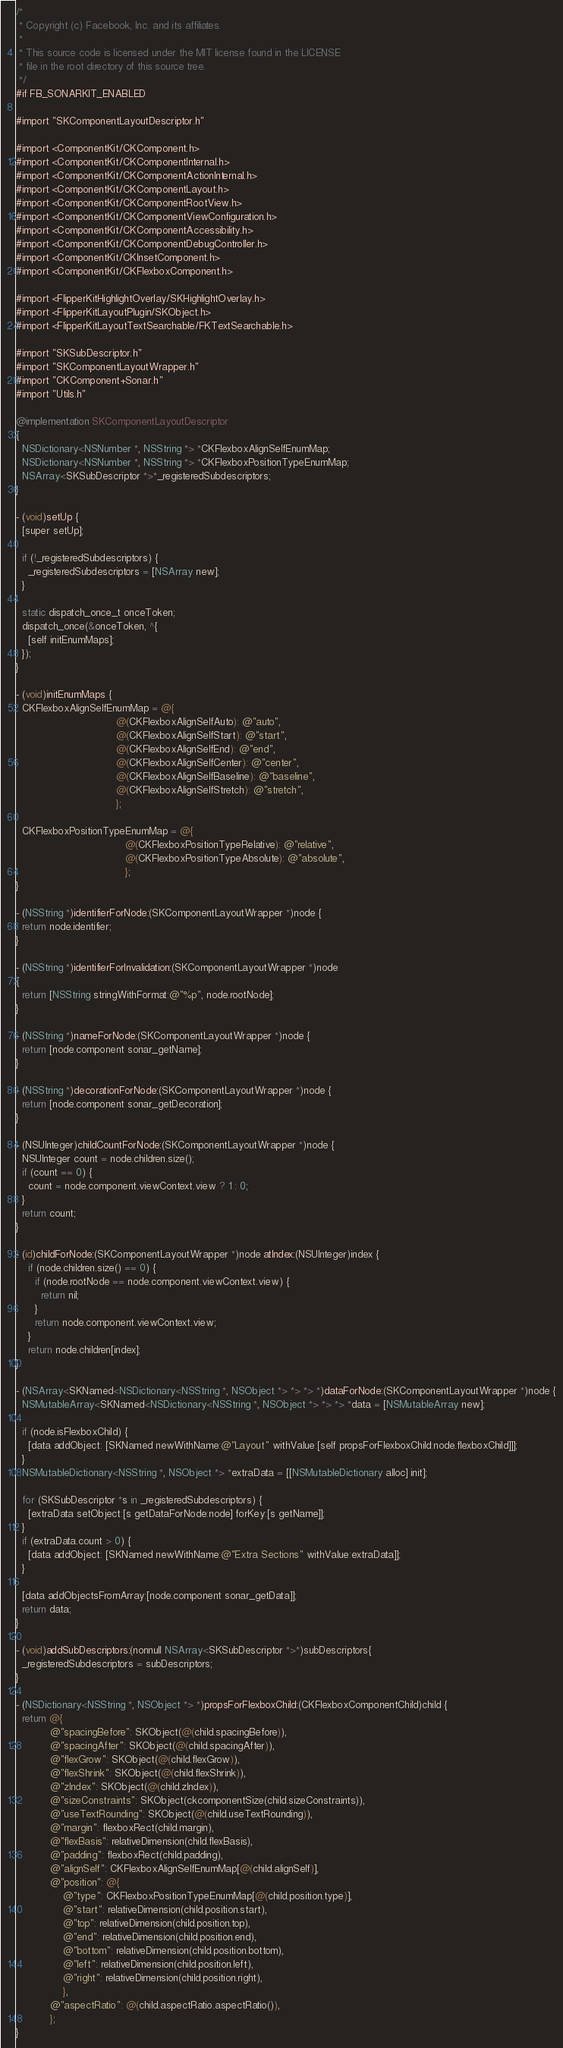<code> <loc_0><loc_0><loc_500><loc_500><_ObjectiveC_>/*
 * Copyright (c) Facebook, Inc. and its affiliates.
 *
 * This source code is licensed under the MIT license found in the LICENSE
 * file in the root directory of this source tree.
 */
#if FB_SONARKIT_ENABLED

#import "SKComponentLayoutDescriptor.h"

#import <ComponentKit/CKComponent.h>
#import <ComponentKit/CKComponentInternal.h>
#import <ComponentKit/CKComponentActionInternal.h>
#import <ComponentKit/CKComponentLayout.h>
#import <ComponentKit/CKComponentRootView.h>
#import <ComponentKit/CKComponentViewConfiguration.h>
#import <ComponentKit/CKComponentAccessibility.h>
#import <ComponentKit/CKComponentDebugController.h>
#import <ComponentKit/CKInsetComponent.h>
#import <ComponentKit/CKFlexboxComponent.h>

#import <FlipperKitHighlightOverlay/SKHighlightOverlay.h>
#import <FlipperKitLayoutPlugin/SKObject.h>
#import <FlipperKitLayoutTextSearchable/FKTextSearchable.h>

#import "SKSubDescriptor.h"
#import "SKComponentLayoutWrapper.h"
#import "CKComponent+Sonar.h"
#import "Utils.h"

@implementation SKComponentLayoutDescriptor
{
  NSDictionary<NSNumber *, NSString *> *CKFlexboxAlignSelfEnumMap;
  NSDictionary<NSNumber *, NSString *> *CKFlexboxPositionTypeEnumMap;
  NSArray<SKSubDescriptor *>*_registeredSubdescriptors;
}

- (void)setUp {
  [super setUp];

  if (!_registeredSubdescriptors) {
    _registeredSubdescriptors = [NSArray new];
  }

  static dispatch_once_t onceToken;
  dispatch_once(&onceToken, ^{
    [self initEnumMaps];
  });
}

- (void)initEnumMaps {
  CKFlexboxAlignSelfEnumMap = @{
                                @(CKFlexboxAlignSelfAuto): @"auto",
                                @(CKFlexboxAlignSelfStart): @"start",
                                @(CKFlexboxAlignSelfEnd): @"end",
                                @(CKFlexboxAlignSelfCenter): @"center",
                                @(CKFlexboxAlignSelfBaseline): @"baseline",
                                @(CKFlexboxAlignSelfStretch): @"stretch",
                                };

  CKFlexboxPositionTypeEnumMap = @{
                                   @(CKFlexboxPositionTypeRelative): @"relative",
                                   @(CKFlexboxPositionTypeAbsolute): @"absolute",
                                   };
}

- (NSString *)identifierForNode:(SKComponentLayoutWrapper *)node {
  return node.identifier;
}

- (NSString *)identifierForInvalidation:(SKComponentLayoutWrapper *)node
{
  return [NSString stringWithFormat:@"%p", node.rootNode];
}

- (NSString *)nameForNode:(SKComponentLayoutWrapper *)node {
  return [node.component sonar_getName];
}

- (NSString *)decorationForNode:(SKComponentLayoutWrapper *)node {
  return [node.component sonar_getDecoration];
}

- (NSUInteger)childCountForNode:(SKComponentLayoutWrapper *)node {
  NSUInteger count = node.children.size();
  if (count == 0) {
    count = node.component.viewContext.view ? 1 : 0;
  }
  return count;
}

- (id)childForNode:(SKComponentLayoutWrapper *)node atIndex:(NSUInteger)index {
    if (node.children.size() == 0) {
      if (node.rootNode == node.component.viewContext.view) {
        return nil;
      }
      return node.component.viewContext.view;
    }
    return node.children[index];
}

- (NSArray<SKNamed<NSDictionary<NSString *, NSObject *> *> *> *)dataForNode:(SKComponentLayoutWrapper *)node {
  NSMutableArray<SKNamed<NSDictionary<NSString *, NSObject *> *> *> *data = [NSMutableArray new];

  if (node.isFlexboxChild) {
    [data addObject: [SKNamed newWithName:@"Layout" withValue:[self propsForFlexboxChild:node.flexboxChild]]];
  }
  NSMutableDictionary<NSString *, NSObject *> *extraData = [[NSMutableDictionary alloc] init];

  for (SKSubDescriptor *s in _registeredSubdescriptors) {
    [extraData setObject:[s getDataForNode:node] forKey:[s getName]];
  }
  if (extraData.count > 0) {
    [data addObject: [SKNamed newWithName:@"Extra Sections" withValue:extraData]];
  }

  [data addObjectsFromArray:[node.component sonar_getData]];
  return data;
}

- (void)addSubDescriptors:(nonnull NSArray<SKSubDescriptor *>*)subDescriptors{
  _registeredSubdescriptors = subDescriptors;
}

- (NSDictionary<NSString *, NSObject *> *)propsForFlexboxChild:(CKFlexboxComponentChild)child {
  return @{
           @"spacingBefore": SKObject(@(child.spacingBefore)),
           @"spacingAfter": SKObject(@(child.spacingAfter)),
           @"flexGrow": SKObject(@(child.flexGrow)),
           @"flexShrink": SKObject(@(child.flexShrink)),
           @"zIndex": SKObject(@(child.zIndex)),
           @"sizeConstraints": SKObject(ckcomponentSize(child.sizeConstraints)),
           @"useTextRounding": SKObject(@(child.useTextRounding)),
           @"margin": flexboxRect(child.margin),
           @"flexBasis": relativeDimension(child.flexBasis),
           @"padding": flexboxRect(child.padding),
           @"alignSelf": CKFlexboxAlignSelfEnumMap[@(child.alignSelf)],
           @"position": @{
               @"type": CKFlexboxPositionTypeEnumMap[@(child.position.type)],
               @"start": relativeDimension(child.position.start),
               @"top": relativeDimension(child.position.top),
               @"end": relativeDimension(child.position.end),
               @"bottom": relativeDimension(child.position.bottom),
               @"left": relativeDimension(child.position.left),
               @"right": relativeDimension(child.position.right),
               },
           @"aspectRatio": @(child.aspectRatio.aspectRatio()),
           };
}
</code> 